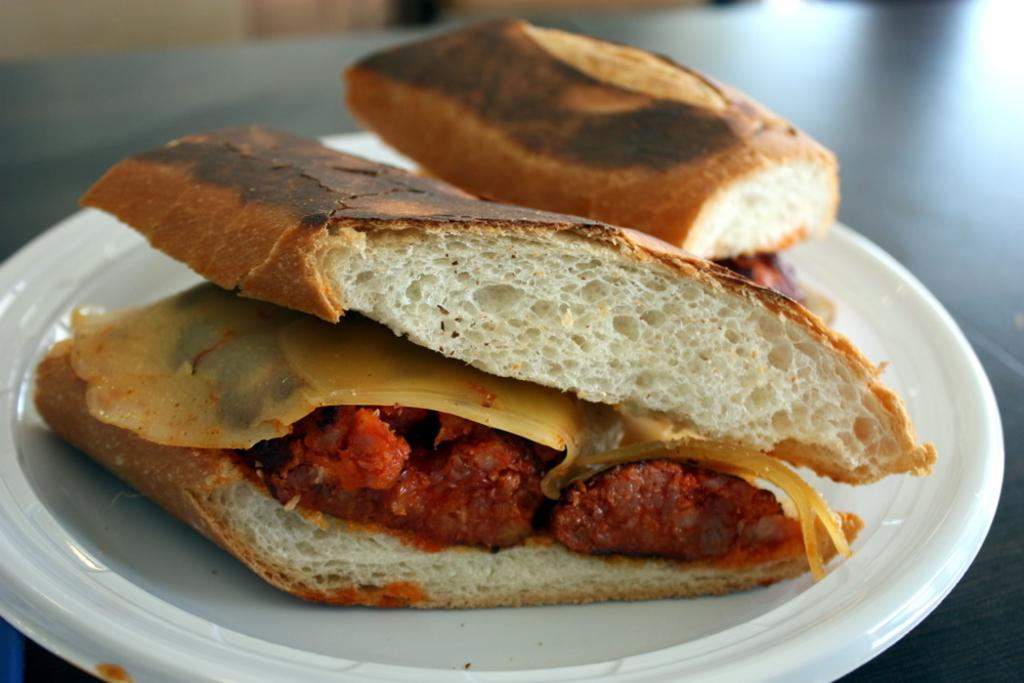What is on the surface in the image? There is a plate on a surface in the image. What is on the plate? The plate contains food. Can you describe the background of the image? The background of the image is blurry. Is there a lamp illuminating the food on the plate in the image? There is no lamp present in the image, so it cannot be determined if it is illuminating the food on the plate. 